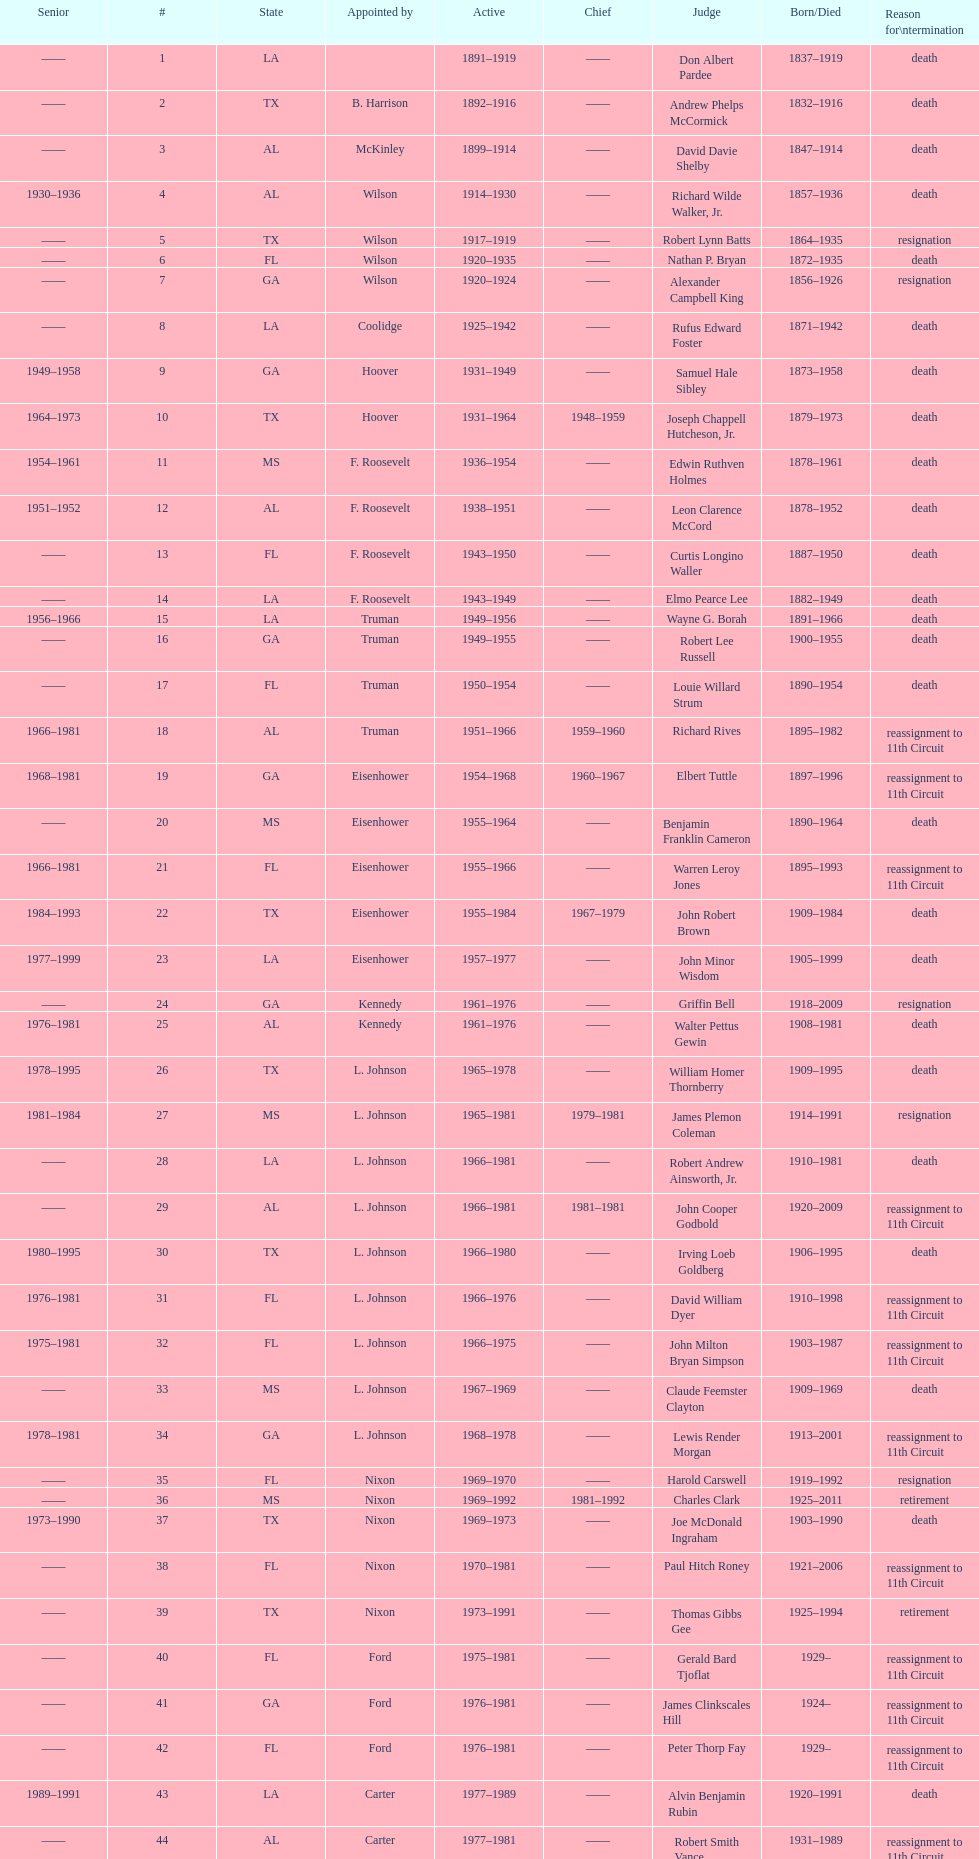How many judges served as chief total? 8. 